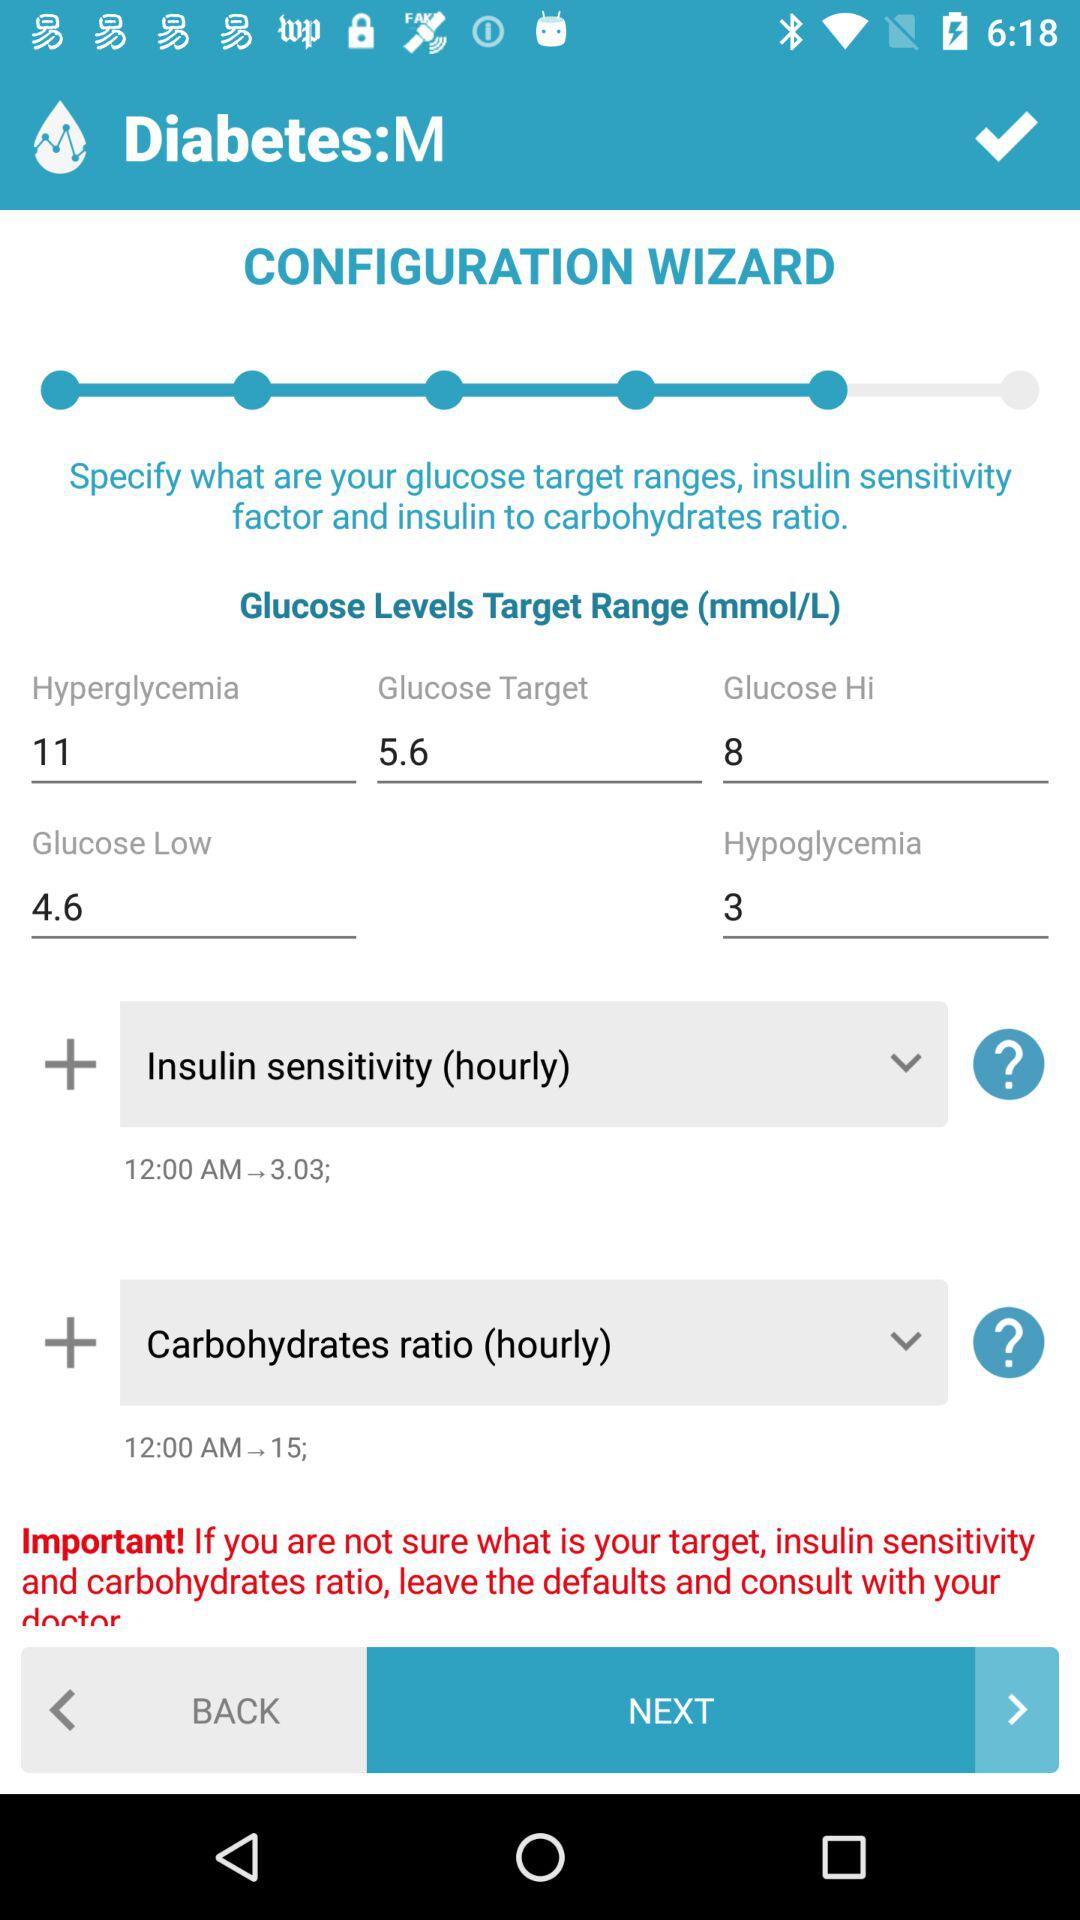What is the hyperglycemia target range? The hyperglycemia target range is 11. 